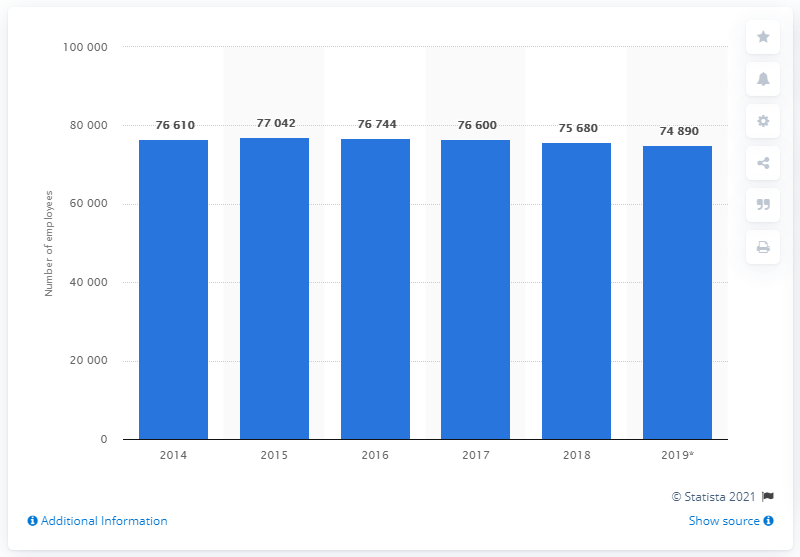List a handful of essential elements in this visual. In 2015, the Italian footwear sector had approximately 76,610 employees. The total number of employees in the Italian footwear sector in 2019 was 74,890. 